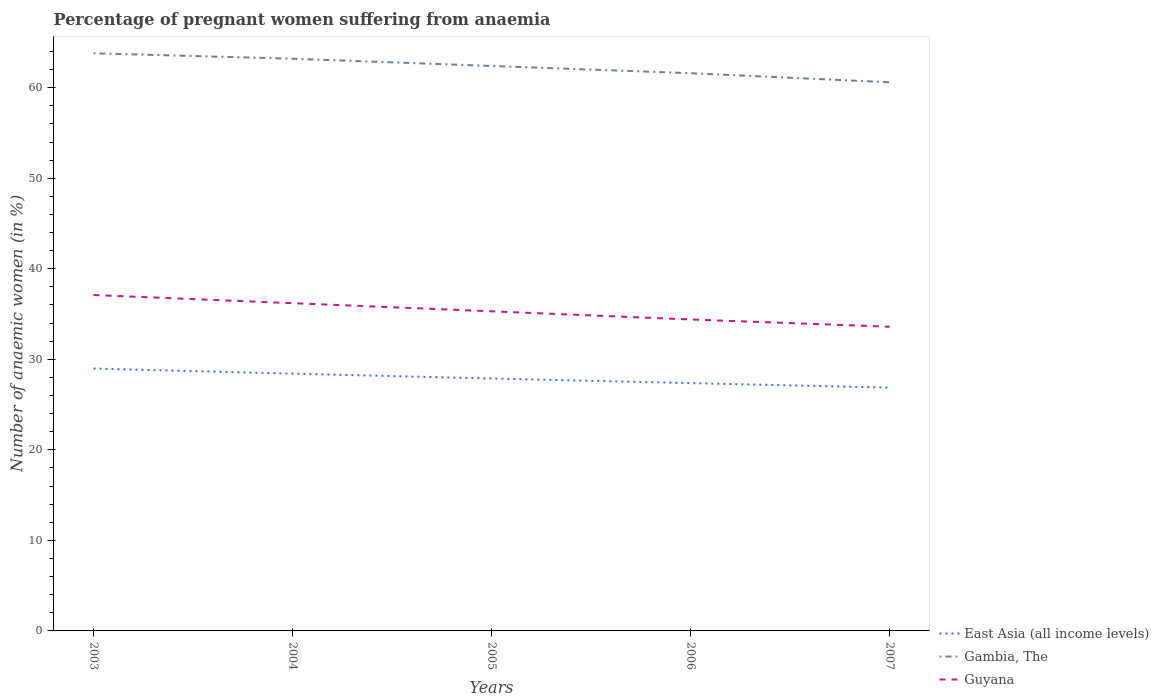Across all years, what is the maximum number of anaemic women in Gambia, The?
Offer a very short reply. 60.6. What is the total number of anaemic women in Gambia, The in the graph?
Your response must be concise. 0.6. Is the number of anaemic women in Gambia, The strictly greater than the number of anaemic women in East Asia (all income levels) over the years?
Keep it short and to the point. No. How many lines are there?
Make the answer very short. 3. How many years are there in the graph?
Give a very brief answer. 5. Are the values on the major ticks of Y-axis written in scientific E-notation?
Your response must be concise. No. Does the graph contain grids?
Your response must be concise. No. What is the title of the graph?
Your answer should be very brief. Percentage of pregnant women suffering from anaemia. What is the label or title of the Y-axis?
Give a very brief answer. Number of anaemic women (in %). What is the Number of anaemic women (in %) of East Asia (all income levels) in 2003?
Give a very brief answer. 28.98. What is the Number of anaemic women (in %) of Gambia, The in 2003?
Ensure brevity in your answer.  63.8. What is the Number of anaemic women (in %) of Guyana in 2003?
Give a very brief answer. 37.1. What is the Number of anaemic women (in %) of East Asia (all income levels) in 2004?
Ensure brevity in your answer.  28.41. What is the Number of anaemic women (in %) of Gambia, The in 2004?
Your answer should be compact. 63.2. What is the Number of anaemic women (in %) of Guyana in 2004?
Provide a short and direct response. 36.2. What is the Number of anaemic women (in %) in East Asia (all income levels) in 2005?
Offer a very short reply. 27.88. What is the Number of anaemic women (in %) of Gambia, The in 2005?
Ensure brevity in your answer.  62.4. What is the Number of anaemic women (in %) of Guyana in 2005?
Provide a short and direct response. 35.3. What is the Number of anaemic women (in %) of East Asia (all income levels) in 2006?
Give a very brief answer. 27.37. What is the Number of anaemic women (in %) in Gambia, The in 2006?
Make the answer very short. 61.6. What is the Number of anaemic women (in %) of Guyana in 2006?
Make the answer very short. 34.4. What is the Number of anaemic women (in %) in East Asia (all income levels) in 2007?
Provide a short and direct response. 26.88. What is the Number of anaemic women (in %) of Gambia, The in 2007?
Make the answer very short. 60.6. What is the Number of anaemic women (in %) of Guyana in 2007?
Keep it short and to the point. 33.6. Across all years, what is the maximum Number of anaemic women (in %) in East Asia (all income levels)?
Provide a short and direct response. 28.98. Across all years, what is the maximum Number of anaemic women (in %) in Gambia, The?
Make the answer very short. 63.8. Across all years, what is the maximum Number of anaemic women (in %) of Guyana?
Your response must be concise. 37.1. Across all years, what is the minimum Number of anaemic women (in %) of East Asia (all income levels)?
Your answer should be compact. 26.88. Across all years, what is the minimum Number of anaemic women (in %) of Gambia, The?
Make the answer very short. 60.6. Across all years, what is the minimum Number of anaemic women (in %) in Guyana?
Give a very brief answer. 33.6. What is the total Number of anaemic women (in %) in East Asia (all income levels) in the graph?
Offer a terse response. 139.52. What is the total Number of anaemic women (in %) of Gambia, The in the graph?
Offer a very short reply. 311.6. What is the total Number of anaemic women (in %) in Guyana in the graph?
Your response must be concise. 176.6. What is the difference between the Number of anaemic women (in %) of East Asia (all income levels) in 2003 and that in 2004?
Keep it short and to the point. 0.57. What is the difference between the Number of anaemic women (in %) of Gambia, The in 2003 and that in 2004?
Provide a short and direct response. 0.6. What is the difference between the Number of anaemic women (in %) of Guyana in 2003 and that in 2004?
Provide a short and direct response. 0.9. What is the difference between the Number of anaemic women (in %) in East Asia (all income levels) in 2003 and that in 2005?
Make the answer very short. 1.1. What is the difference between the Number of anaemic women (in %) of East Asia (all income levels) in 2003 and that in 2006?
Provide a short and direct response. 1.61. What is the difference between the Number of anaemic women (in %) in East Asia (all income levels) in 2003 and that in 2007?
Provide a succinct answer. 2.1. What is the difference between the Number of anaemic women (in %) of Gambia, The in 2003 and that in 2007?
Offer a very short reply. 3.2. What is the difference between the Number of anaemic women (in %) in East Asia (all income levels) in 2004 and that in 2005?
Give a very brief answer. 0.53. What is the difference between the Number of anaemic women (in %) of Gambia, The in 2004 and that in 2005?
Give a very brief answer. 0.8. What is the difference between the Number of anaemic women (in %) in East Asia (all income levels) in 2004 and that in 2006?
Offer a terse response. 1.04. What is the difference between the Number of anaemic women (in %) in East Asia (all income levels) in 2004 and that in 2007?
Offer a very short reply. 1.54. What is the difference between the Number of anaemic women (in %) of Guyana in 2004 and that in 2007?
Your answer should be very brief. 2.6. What is the difference between the Number of anaemic women (in %) in East Asia (all income levels) in 2005 and that in 2006?
Your answer should be compact. 0.51. What is the difference between the Number of anaemic women (in %) in Gambia, The in 2005 and that in 2006?
Your answer should be very brief. 0.8. What is the difference between the Number of anaemic women (in %) in East Asia (all income levels) in 2005 and that in 2007?
Provide a succinct answer. 1. What is the difference between the Number of anaemic women (in %) in Gambia, The in 2005 and that in 2007?
Keep it short and to the point. 1.8. What is the difference between the Number of anaemic women (in %) in East Asia (all income levels) in 2006 and that in 2007?
Provide a succinct answer. 0.49. What is the difference between the Number of anaemic women (in %) of East Asia (all income levels) in 2003 and the Number of anaemic women (in %) of Gambia, The in 2004?
Offer a very short reply. -34.22. What is the difference between the Number of anaemic women (in %) of East Asia (all income levels) in 2003 and the Number of anaemic women (in %) of Guyana in 2004?
Make the answer very short. -7.22. What is the difference between the Number of anaemic women (in %) in Gambia, The in 2003 and the Number of anaemic women (in %) in Guyana in 2004?
Provide a succinct answer. 27.6. What is the difference between the Number of anaemic women (in %) in East Asia (all income levels) in 2003 and the Number of anaemic women (in %) in Gambia, The in 2005?
Keep it short and to the point. -33.42. What is the difference between the Number of anaemic women (in %) in East Asia (all income levels) in 2003 and the Number of anaemic women (in %) in Guyana in 2005?
Your answer should be compact. -6.32. What is the difference between the Number of anaemic women (in %) in East Asia (all income levels) in 2003 and the Number of anaemic women (in %) in Gambia, The in 2006?
Provide a short and direct response. -32.62. What is the difference between the Number of anaemic women (in %) of East Asia (all income levels) in 2003 and the Number of anaemic women (in %) of Guyana in 2006?
Provide a succinct answer. -5.42. What is the difference between the Number of anaemic women (in %) of Gambia, The in 2003 and the Number of anaemic women (in %) of Guyana in 2006?
Offer a very short reply. 29.4. What is the difference between the Number of anaemic women (in %) of East Asia (all income levels) in 2003 and the Number of anaemic women (in %) of Gambia, The in 2007?
Provide a succinct answer. -31.62. What is the difference between the Number of anaemic women (in %) of East Asia (all income levels) in 2003 and the Number of anaemic women (in %) of Guyana in 2007?
Your response must be concise. -4.62. What is the difference between the Number of anaemic women (in %) of Gambia, The in 2003 and the Number of anaemic women (in %) of Guyana in 2007?
Keep it short and to the point. 30.2. What is the difference between the Number of anaemic women (in %) in East Asia (all income levels) in 2004 and the Number of anaemic women (in %) in Gambia, The in 2005?
Your response must be concise. -33.99. What is the difference between the Number of anaemic women (in %) of East Asia (all income levels) in 2004 and the Number of anaemic women (in %) of Guyana in 2005?
Provide a succinct answer. -6.89. What is the difference between the Number of anaemic women (in %) of Gambia, The in 2004 and the Number of anaemic women (in %) of Guyana in 2005?
Ensure brevity in your answer.  27.9. What is the difference between the Number of anaemic women (in %) in East Asia (all income levels) in 2004 and the Number of anaemic women (in %) in Gambia, The in 2006?
Ensure brevity in your answer.  -33.19. What is the difference between the Number of anaemic women (in %) of East Asia (all income levels) in 2004 and the Number of anaemic women (in %) of Guyana in 2006?
Your answer should be compact. -5.99. What is the difference between the Number of anaemic women (in %) of Gambia, The in 2004 and the Number of anaemic women (in %) of Guyana in 2006?
Keep it short and to the point. 28.8. What is the difference between the Number of anaemic women (in %) of East Asia (all income levels) in 2004 and the Number of anaemic women (in %) of Gambia, The in 2007?
Provide a short and direct response. -32.19. What is the difference between the Number of anaemic women (in %) of East Asia (all income levels) in 2004 and the Number of anaemic women (in %) of Guyana in 2007?
Ensure brevity in your answer.  -5.19. What is the difference between the Number of anaemic women (in %) in Gambia, The in 2004 and the Number of anaemic women (in %) in Guyana in 2007?
Keep it short and to the point. 29.6. What is the difference between the Number of anaemic women (in %) in East Asia (all income levels) in 2005 and the Number of anaemic women (in %) in Gambia, The in 2006?
Offer a terse response. -33.72. What is the difference between the Number of anaemic women (in %) in East Asia (all income levels) in 2005 and the Number of anaemic women (in %) in Guyana in 2006?
Ensure brevity in your answer.  -6.52. What is the difference between the Number of anaemic women (in %) in East Asia (all income levels) in 2005 and the Number of anaemic women (in %) in Gambia, The in 2007?
Your response must be concise. -32.72. What is the difference between the Number of anaemic women (in %) of East Asia (all income levels) in 2005 and the Number of anaemic women (in %) of Guyana in 2007?
Give a very brief answer. -5.72. What is the difference between the Number of anaemic women (in %) in Gambia, The in 2005 and the Number of anaemic women (in %) in Guyana in 2007?
Your response must be concise. 28.8. What is the difference between the Number of anaemic women (in %) of East Asia (all income levels) in 2006 and the Number of anaemic women (in %) of Gambia, The in 2007?
Offer a very short reply. -33.23. What is the difference between the Number of anaemic women (in %) in East Asia (all income levels) in 2006 and the Number of anaemic women (in %) in Guyana in 2007?
Keep it short and to the point. -6.23. What is the average Number of anaemic women (in %) in East Asia (all income levels) per year?
Ensure brevity in your answer.  27.9. What is the average Number of anaemic women (in %) in Gambia, The per year?
Offer a terse response. 62.32. What is the average Number of anaemic women (in %) in Guyana per year?
Provide a succinct answer. 35.32. In the year 2003, what is the difference between the Number of anaemic women (in %) of East Asia (all income levels) and Number of anaemic women (in %) of Gambia, The?
Provide a short and direct response. -34.82. In the year 2003, what is the difference between the Number of anaemic women (in %) in East Asia (all income levels) and Number of anaemic women (in %) in Guyana?
Ensure brevity in your answer.  -8.12. In the year 2003, what is the difference between the Number of anaemic women (in %) of Gambia, The and Number of anaemic women (in %) of Guyana?
Provide a short and direct response. 26.7. In the year 2004, what is the difference between the Number of anaemic women (in %) in East Asia (all income levels) and Number of anaemic women (in %) in Gambia, The?
Offer a terse response. -34.79. In the year 2004, what is the difference between the Number of anaemic women (in %) of East Asia (all income levels) and Number of anaemic women (in %) of Guyana?
Your answer should be very brief. -7.79. In the year 2004, what is the difference between the Number of anaemic women (in %) in Gambia, The and Number of anaemic women (in %) in Guyana?
Provide a succinct answer. 27. In the year 2005, what is the difference between the Number of anaemic women (in %) in East Asia (all income levels) and Number of anaemic women (in %) in Gambia, The?
Offer a very short reply. -34.52. In the year 2005, what is the difference between the Number of anaemic women (in %) in East Asia (all income levels) and Number of anaemic women (in %) in Guyana?
Keep it short and to the point. -7.42. In the year 2005, what is the difference between the Number of anaemic women (in %) in Gambia, The and Number of anaemic women (in %) in Guyana?
Ensure brevity in your answer.  27.1. In the year 2006, what is the difference between the Number of anaemic women (in %) in East Asia (all income levels) and Number of anaemic women (in %) in Gambia, The?
Make the answer very short. -34.23. In the year 2006, what is the difference between the Number of anaemic women (in %) of East Asia (all income levels) and Number of anaemic women (in %) of Guyana?
Keep it short and to the point. -7.03. In the year 2006, what is the difference between the Number of anaemic women (in %) in Gambia, The and Number of anaemic women (in %) in Guyana?
Provide a short and direct response. 27.2. In the year 2007, what is the difference between the Number of anaemic women (in %) in East Asia (all income levels) and Number of anaemic women (in %) in Gambia, The?
Offer a very short reply. -33.72. In the year 2007, what is the difference between the Number of anaemic women (in %) of East Asia (all income levels) and Number of anaemic women (in %) of Guyana?
Your response must be concise. -6.72. What is the ratio of the Number of anaemic women (in %) in East Asia (all income levels) in 2003 to that in 2004?
Offer a very short reply. 1.02. What is the ratio of the Number of anaemic women (in %) in Gambia, The in 2003 to that in 2004?
Your answer should be compact. 1.01. What is the ratio of the Number of anaemic women (in %) in Guyana in 2003 to that in 2004?
Offer a terse response. 1.02. What is the ratio of the Number of anaemic women (in %) in East Asia (all income levels) in 2003 to that in 2005?
Your answer should be very brief. 1.04. What is the ratio of the Number of anaemic women (in %) of Gambia, The in 2003 to that in 2005?
Keep it short and to the point. 1.02. What is the ratio of the Number of anaemic women (in %) in Guyana in 2003 to that in 2005?
Give a very brief answer. 1.05. What is the ratio of the Number of anaemic women (in %) in East Asia (all income levels) in 2003 to that in 2006?
Ensure brevity in your answer.  1.06. What is the ratio of the Number of anaemic women (in %) in Gambia, The in 2003 to that in 2006?
Provide a succinct answer. 1.04. What is the ratio of the Number of anaemic women (in %) in Guyana in 2003 to that in 2006?
Give a very brief answer. 1.08. What is the ratio of the Number of anaemic women (in %) of East Asia (all income levels) in 2003 to that in 2007?
Provide a short and direct response. 1.08. What is the ratio of the Number of anaemic women (in %) in Gambia, The in 2003 to that in 2007?
Ensure brevity in your answer.  1.05. What is the ratio of the Number of anaemic women (in %) in Guyana in 2003 to that in 2007?
Your response must be concise. 1.1. What is the ratio of the Number of anaemic women (in %) of East Asia (all income levels) in 2004 to that in 2005?
Make the answer very short. 1.02. What is the ratio of the Number of anaemic women (in %) in Gambia, The in 2004 to that in 2005?
Your answer should be compact. 1.01. What is the ratio of the Number of anaemic women (in %) in Guyana in 2004 to that in 2005?
Make the answer very short. 1.03. What is the ratio of the Number of anaemic women (in %) in East Asia (all income levels) in 2004 to that in 2006?
Your answer should be very brief. 1.04. What is the ratio of the Number of anaemic women (in %) of Gambia, The in 2004 to that in 2006?
Provide a short and direct response. 1.03. What is the ratio of the Number of anaemic women (in %) of Guyana in 2004 to that in 2006?
Ensure brevity in your answer.  1.05. What is the ratio of the Number of anaemic women (in %) in East Asia (all income levels) in 2004 to that in 2007?
Offer a very short reply. 1.06. What is the ratio of the Number of anaemic women (in %) in Gambia, The in 2004 to that in 2007?
Make the answer very short. 1.04. What is the ratio of the Number of anaemic women (in %) in Guyana in 2004 to that in 2007?
Keep it short and to the point. 1.08. What is the ratio of the Number of anaemic women (in %) of East Asia (all income levels) in 2005 to that in 2006?
Give a very brief answer. 1.02. What is the ratio of the Number of anaemic women (in %) in Gambia, The in 2005 to that in 2006?
Make the answer very short. 1.01. What is the ratio of the Number of anaemic women (in %) of Guyana in 2005 to that in 2006?
Give a very brief answer. 1.03. What is the ratio of the Number of anaemic women (in %) in East Asia (all income levels) in 2005 to that in 2007?
Offer a very short reply. 1.04. What is the ratio of the Number of anaemic women (in %) in Gambia, The in 2005 to that in 2007?
Keep it short and to the point. 1.03. What is the ratio of the Number of anaemic women (in %) in Guyana in 2005 to that in 2007?
Offer a very short reply. 1.05. What is the ratio of the Number of anaemic women (in %) in East Asia (all income levels) in 2006 to that in 2007?
Keep it short and to the point. 1.02. What is the ratio of the Number of anaemic women (in %) of Gambia, The in 2006 to that in 2007?
Offer a terse response. 1.02. What is the ratio of the Number of anaemic women (in %) in Guyana in 2006 to that in 2007?
Your answer should be compact. 1.02. What is the difference between the highest and the second highest Number of anaemic women (in %) of East Asia (all income levels)?
Your answer should be very brief. 0.57. What is the difference between the highest and the lowest Number of anaemic women (in %) of East Asia (all income levels)?
Provide a succinct answer. 2.1. What is the difference between the highest and the lowest Number of anaemic women (in %) of Guyana?
Provide a short and direct response. 3.5. 